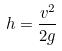Convert formula to latex. <formula><loc_0><loc_0><loc_500><loc_500>h = \frac { v ^ { 2 } } { 2 g }</formula> 